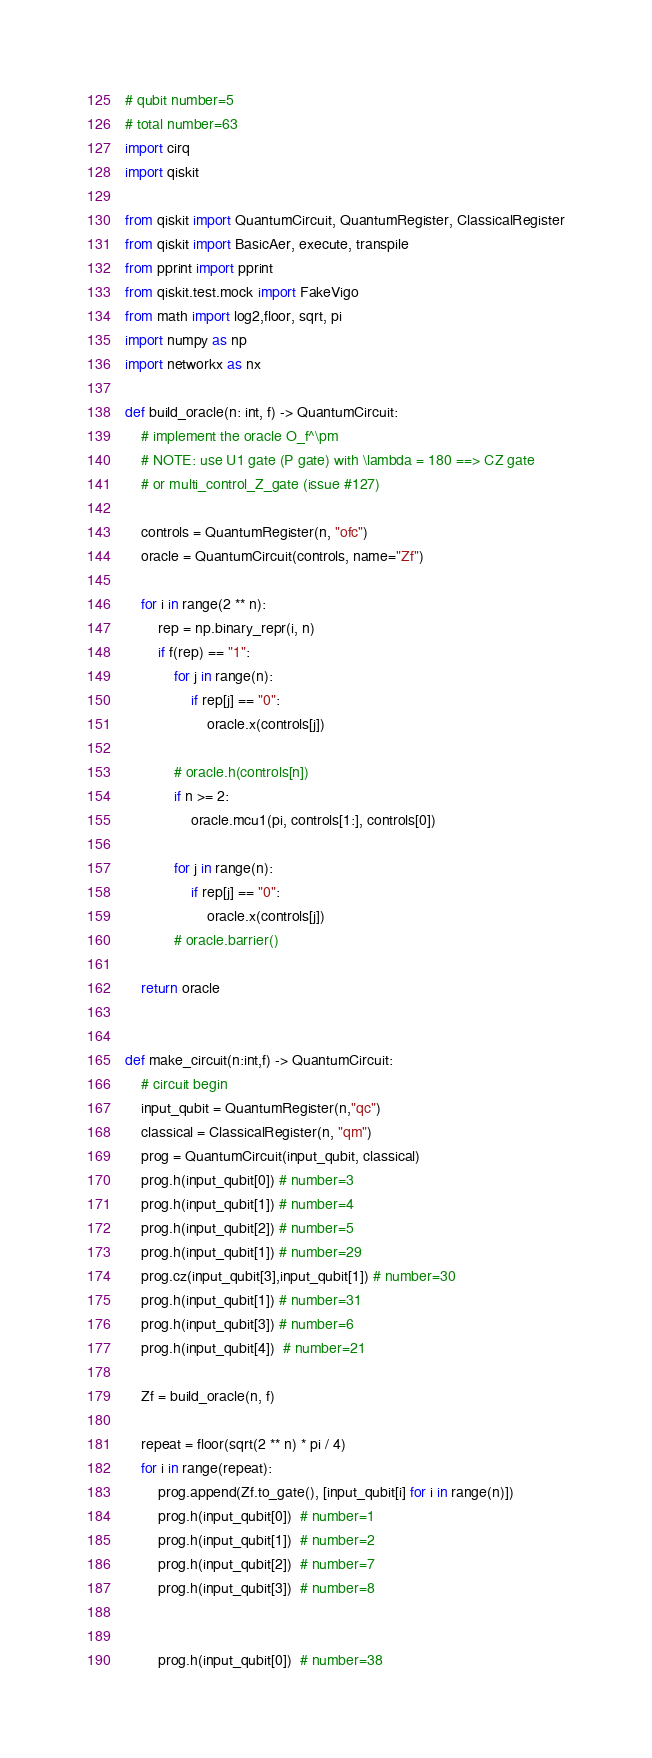<code> <loc_0><loc_0><loc_500><loc_500><_Python_># qubit number=5
# total number=63
import cirq
import qiskit

from qiskit import QuantumCircuit, QuantumRegister, ClassicalRegister
from qiskit import BasicAer, execute, transpile
from pprint import pprint
from qiskit.test.mock import FakeVigo
from math import log2,floor, sqrt, pi
import numpy as np
import networkx as nx

def build_oracle(n: int, f) -> QuantumCircuit:
    # implement the oracle O_f^\pm
    # NOTE: use U1 gate (P gate) with \lambda = 180 ==> CZ gate
    # or multi_control_Z_gate (issue #127)

    controls = QuantumRegister(n, "ofc")
    oracle = QuantumCircuit(controls, name="Zf")

    for i in range(2 ** n):
        rep = np.binary_repr(i, n)
        if f(rep) == "1":
            for j in range(n):
                if rep[j] == "0":
                    oracle.x(controls[j])

            # oracle.h(controls[n])
            if n >= 2:
                oracle.mcu1(pi, controls[1:], controls[0])

            for j in range(n):
                if rep[j] == "0":
                    oracle.x(controls[j])
            # oracle.barrier()

    return oracle


def make_circuit(n:int,f) -> QuantumCircuit:
    # circuit begin
    input_qubit = QuantumRegister(n,"qc")
    classical = ClassicalRegister(n, "qm")
    prog = QuantumCircuit(input_qubit, classical)
    prog.h(input_qubit[0]) # number=3
    prog.h(input_qubit[1]) # number=4
    prog.h(input_qubit[2]) # number=5
    prog.h(input_qubit[1]) # number=29
    prog.cz(input_qubit[3],input_qubit[1]) # number=30
    prog.h(input_qubit[1]) # number=31
    prog.h(input_qubit[3]) # number=6
    prog.h(input_qubit[4])  # number=21

    Zf = build_oracle(n, f)

    repeat = floor(sqrt(2 ** n) * pi / 4)
    for i in range(repeat):
        prog.append(Zf.to_gate(), [input_qubit[i] for i in range(n)])
        prog.h(input_qubit[0])  # number=1
        prog.h(input_qubit[1])  # number=2
        prog.h(input_qubit[2])  # number=7
        prog.h(input_qubit[3])  # number=8


        prog.h(input_qubit[0])  # number=38</code> 